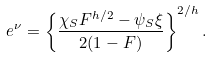Convert formula to latex. <formula><loc_0><loc_0><loc_500><loc_500>e ^ { \nu } = \left \{ \frac { \chi _ { S } F ^ { h / 2 } - \psi _ { S } \xi } { 2 ( 1 - F ) } \right \} ^ { 2 / h } .</formula> 